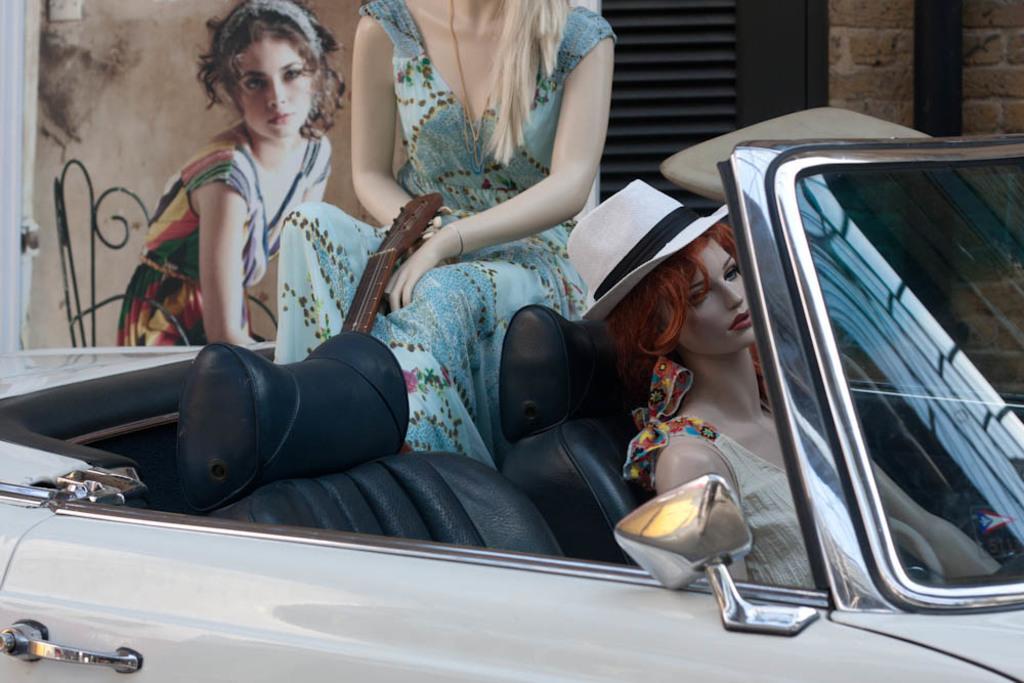Describe this image in one or two sentences. In this car there are dolls and guitar. On a wall there is a picture of a woman sitting on a chair. 